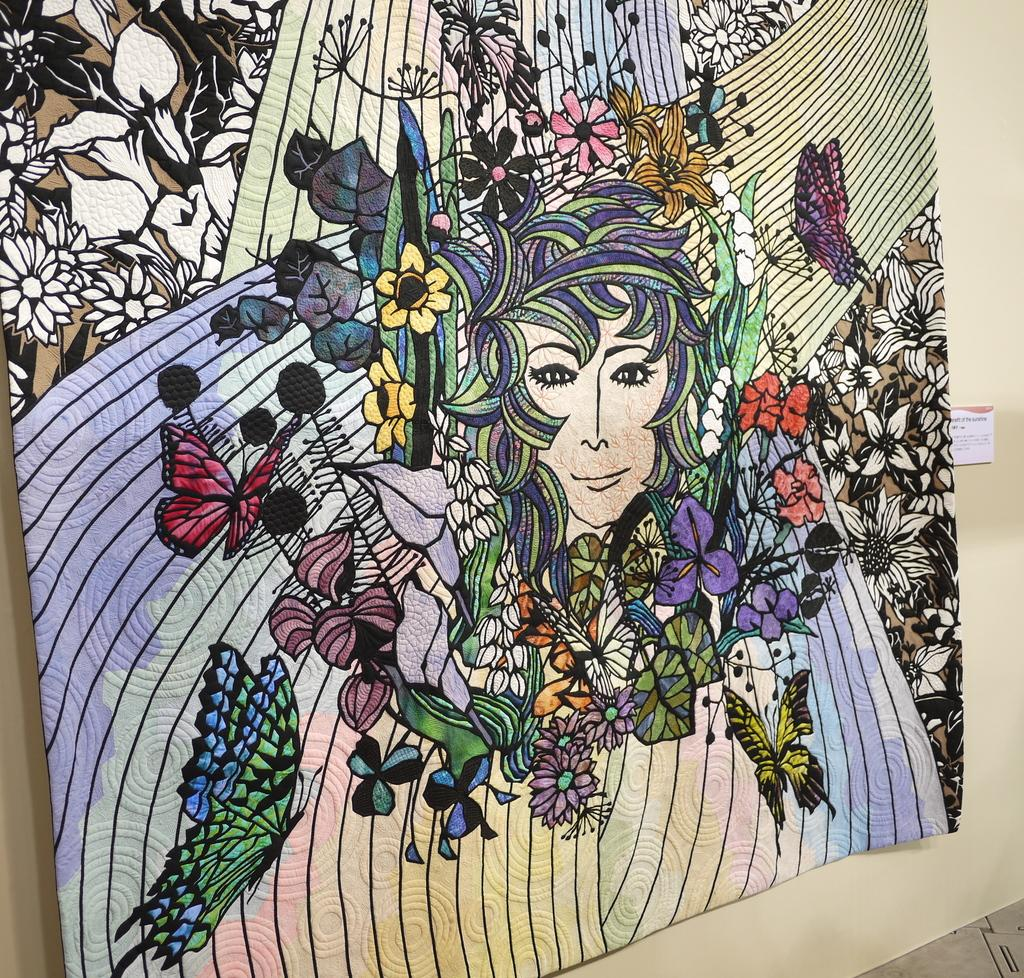What is placed on the table in the image? There is a cloth on the table in the image. What type of bulb is being discussed in the image? There is no discussion or bulb present in the image; it only features a cloth on the table. 